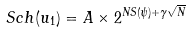<formula> <loc_0><loc_0><loc_500><loc_500>S c h ( u _ { 1 } ) = A \times 2 ^ { N S ( \psi ) + \gamma \sqrt { N } }</formula> 